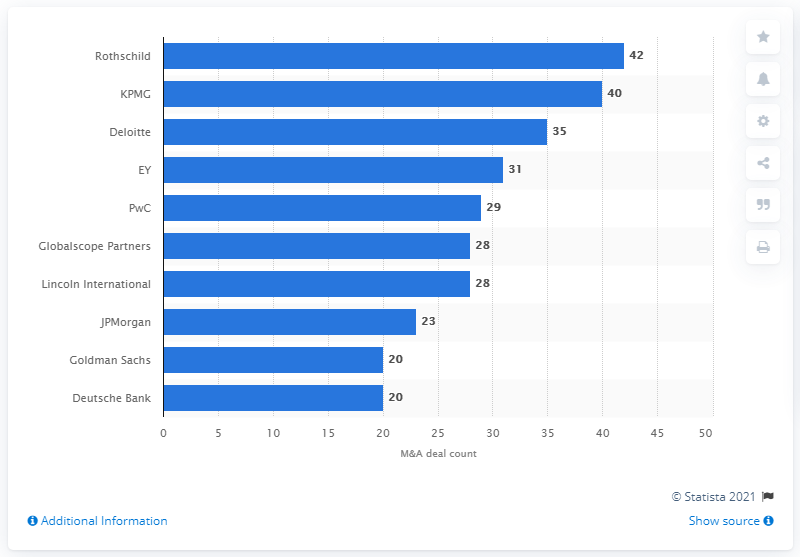Outline some significant characteristics in this image. In 2016, Rothschild was the top advisor for mergers and acquisitions in Germany. In 2016, the Rothschild had 42 deals. 